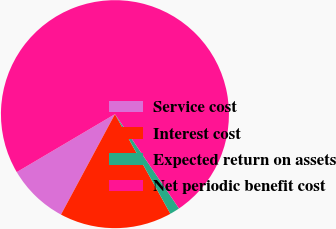Convert chart to OTSL. <chart><loc_0><loc_0><loc_500><loc_500><pie_chart><fcel>Service cost<fcel>Interest cost<fcel>Expected return on assets<fcel>Net periodic benefit cost<nl><fcel>8.67%<fcel>15.93%<fcel>1.41%<fcel>73.99%<nl></chart> 